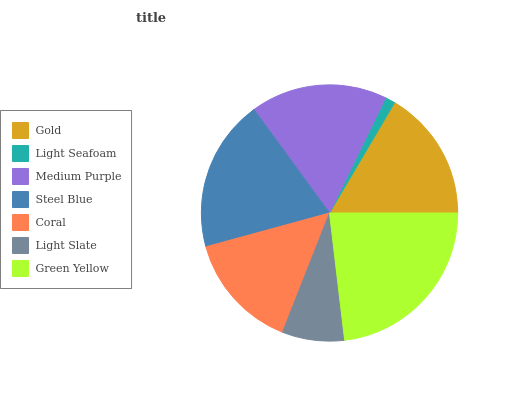Is Light Seafoam the minimum?
Answer yes or no. Yes. Is Green Yellow the maximum?
Answer yes or no. Yes. Is Medium Purple the minimum?
Answer yes or no. No. Is Medium Purple the maximum?
Answer yes or no. No. Is Medium Purple greater than Light Seafoam?
Answer yes or no. Yes. Is Light Seafoam less than Medium Purple?
Answer yes or no. Yes. Is Light Seafoam greater than Medium Purple?
Answer yes or no. No. Is Medium Purple less than Light Seafoam?
Answer yes or no. No. Is Gold the high median?
Answer yes or no. Yes. Is Gold the low median?
Answer yes or no. Yes. Is Light Slate the high median?
Answer yes or no. No. Is Steel Blue the low median?
Answer yes or no. No. 